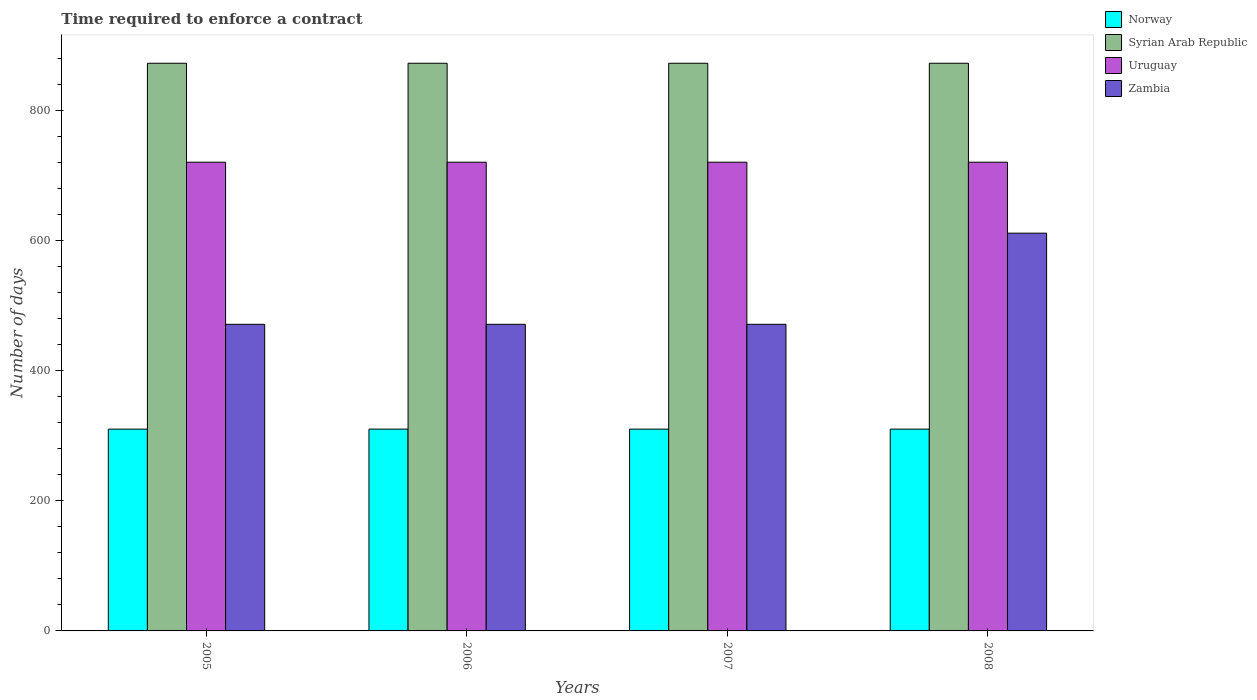How many different coloured bars are there?
Keep it short and to the point. 4. Are the number of bars per tick equal to the number of legend labels?
Make the answer very short. Yes. Are the number of bars on each tick of the X-axis equal?
Your answer should be very brief. Yes. What is the number of days required to enforce a contract in Uruguay in 2006?
Give a very brief answer. 720. Across all years, what is the maximum number of days required to enforce a contract in Syrian Arab Republic?
Ensure brevity in your answer.  872. Across all years, what is the minimum number of days required to enforce a contract in Zambia?
Ensure brevity in your answer.  471. What is the total number of days required to enforce a contract in Uruguay in the graph?
Offer a terse response. 2880. What is the difference between the number of days required to enforce a contract in Uruguay in 2007 and the number of days required to enforce a contract in Norway in 2005?
Your response must be concise. 410. What is the average number of days required to enforce a contract in Norway per year?
Your answer should be very brief. 310. In the year 2006, what is the difference between the number of days required to enforce a contract in Zambia and number of days required to enforce a contract in Uruguay?
Provide a succinct answer. -249. Is the number of days required to enforce a contract in Norway in 2006 less than that in 2008?
Offer a very short reply. No. What is the difference between the highest and the second highest number of days required to enforce a contract in Norway?
Your answer should be compact. 0. What is the difference between the highest and the lowest number of days required to enforce a contract in Uruguay?
Your answer should be very brief. 0. Is it the case that in every year, the sum of the number of days required to enforce a contract in Norway and number of days required to enforce a contract in Syrian Arab Republic is greater than the sum of number of days required to enforce a contract in Uruguay and number of days required to enforce a contract in Zambia?
Your answer should be compact. No. What does the 2nd bar from the left in 2007 represents?
Ensure brevity in your answer.  Syrian Arab Republic. What does the 2nd bar from the right in 2008 represents?
Your response must be concise. Uruguay. Are all the bars in the graph horizontal?
Provide a short and direct response. No. How many years are there in the graph?
Provide a short and direct response. 4. Does the graph contain any zero values?
Provide a short and direct response. No. Does the graph contain grids?
Offer a terse response. No. Where does the legend appear in the graph?
Provide a succinct answer. Top right. What is the title of the graph?
Your response must be concise. Time required to enforce a contract. Does "Moldova" appear as one of the legend labels in the graph?
Give a very brief answer. No. What is the label or title of the X-axis?
Keep it short and to the point. Years. What is the label or title of the Y-axis?
Your answer should be compact. Number of days. What is the Number of days of Norway in 2005?
Your answer should be very brief. 310. What is the Number of days in Syrian Arab Republic in 2005?
Ensure brevity in your answer.  872. What is the Number of days of Uruguay in 2005?
Keep it short and to the point. 720. What is the Number of days in Zambia in 2005?
Keep it short and to the point. 471. What is the Number of days in Norway in 2006?
Give a very brief answer. 310. What is the Number of days of Syrian Arab Republic in 2006?
Provide a short and direct response. 872. What is the Number of days of Uruguay in 2006?
Provide a succinct answer. 720. What is the Number of days of Zambia in 2006?
Ensure brevity in your answer.  471. What is the Number of days of Norway in 2007?
Provide a succinct answer. 310. What is the Number of days in Syrian Arab Republic in 2007?
Provide a succinct answer. 872. What is the Number of days in Uruguay in 2007?
Offer a terse response. 720. What is the Number of days of Zambia in 2007?
Your answer should be very brief. 471. What is the Number of days of Norway in 2008?
Offer a terse response. 310. What is the Number of days of Syrian Arab Republic in 2008?
Your answer should be compact. 872. What is the Number of days in Uruguay in 2008?
Provide a succinct answer. 720. What is the Number of days in Zambia in 2008?
Provide a short and direct response. 611. Across all years, what is the maximum Number of days in Norway?
Ensure brevity in your answer.  310. Across all years, what is the maximum Number of days in Syrian Arab Republic?
Your answer should be compact. 872. Across all years, what is the maximum Number of days of Uruguay?
Your answer should be compact. 720. Across all years, what is the maximum Number of days in Zambia?
Give a very brief answer. 611. Across all years, what is the minimum Number of days in Norway?
Keep it short and to the point. 310. Across all years, what is the minimum Number of days in Syrian Arab Republic?
Your response must be concise. 872. Across all years, what is the minimum Number of days of Uruguay?
Your response must be concise. 720. Across all years, what is the minimum Number of days of Zambia?
Your answer should be very brief. 471. What is the total Number of days of Norway in the graph?
Keep it short and to the point. 1240. What is the total Number of days in Syrian Arab Republic in the graph?
Your answer should be very brief. 3488. What is the total Number of days in Uruguay in the graph?
Provide a short and direct response. 2880. What is the total Number of days in Zambia in the graph?
Your answer should be very brief. 2024. What is the difference between the Number of days in Norway in 2005 and that in 2006?
Provide a short and direct response. 0. What is the difference between the Number of days in Uruguay in 2005 and that in 2006?
Offer a terse response. 0. What is the difference between the Number of days in Norway in 2005 and that in 2007?
Offer a terse response. 0. What is the difference between the Number of days in Uruguay in 2005 and that in 2007?
Offer a very short reply. 0. What is the difference between the Number of days of Norway in 2005 and that in 2008?
Give a very brief answer. 0. What is the difference between the Number of days of Syrian Arab Republic in 2005 and that in 2008?
Provide a succinct answer. 0. What is the difference between the Number of days in Zambia in 2005 and that in 2008?
Make the answer very short. -140. What is the difference between the Number of days in Norway in 2006 and that in 2007?
Offer a very short reply. 0. What is the difference between the Number of days in Zambia in 2006 and that in 2007?
Your response must be concise. 0. What is the difference between the Number of days of Norway in 2006 and that in 2008?
Provide a short and direct response. 0. What is the difference between the Number of days in Zambia in 2006 and that in 2008?
Provide a succinct answer. -140. What is the difference between the Number of days in Norway in 2007 and that in 2008?
Your response must be concise. 0. What is the difference between the Number of days of Syrian Arab Republic in 2007 and that in 2008?
Provide a succinct answer. 0. What is the difference between the Number of days in Zambia in 2007 and that in 2008?
Provide a short and direct response. -140. What is the difference between the Number of days of Norway in 2005 and the Number of days of Syrian Arab Republic in 2006?
Your answer should be very brief. -562. What is the difference between the Number of days in Norway in 2005 and the Number of days in Uruguay in 2006?
Your response must be concise. -410. What is the difference between the Number of days of Norway in 2005 and the Number of days of Zambia in 2006?
Give a very brief answer. -161. What is the difference between the Number of days of Syrian Arab Republic in 2005 and the Number of days of Uruguay in 2006?
Your answer should be compact. 152. What is the difference between the Number of days of Syrian Arab Republic in 2005 and the Number of days of Zambia in 2006?
Your response must be concise. 401. What is the difference between the Number of days of Uruguay in 2005 and the Number of days of Zambia in 2006?
Your answer should be very brief. 249. What is the difference between the Number of days in Norway in 2005 and the Number of days in Syrian Arab Republic in 2007?
Make the answer very short. -562. What is the difference between the Number of days in Norway in 2005 and the Number of days in Uruguay in 2007?
Provide a succinct answer. -410. What is the difference between the Number of days in Norway in 2005 and the Number of days in Zambia in 2007?
Make the answer very short. -161. What is the difference between the Number of days of Syrian Arab Republic in 2005 and the Number of days of Uruguay in 2007?
Give a very brief answer. 152. What is the difference between the Number of days of Syrian Arab Republic in 2005 and the Number of days of Zambia in 2007?
Your response must be concise. 401. What is the difference between the Number of days of Uruguay in 2005 and the Number of days of Zambia in 2007?
Provide a short and direct response. 249. What is the difference between the Number of days of Norway in 2005 and the Number of days of Syrian Arab Republic in 2008?
Make the answer very short. -562. What is the difference between the Number of days in Norway in 2005 and the Number of days in Uruguay in 2008?
Offer a terse response. -410. What is the difference between the Number of days in Norway in 2005 and the Number of days in Zambia in 2008?
Make the answer very short. -301. What is the difference between the Number of days of Syrian Arab Republic in 2005 and the Number of days of Uruguay in 2008?
Give a very brief answer. 152. What is the difference between the Number of days of Syrian Arab Republic in 2005 and the Number of days of Zambia in 2008?
Your response must be concise. 261. What is the difference between the Number of days of Uruguay in 2005 and the Number of days of Zambia in 2008?
Provide a short and direct response. 109. What is the difference between the Number of days in Norway in 2006 and the Number of days in Syrian Arab Republic in 2007?
Ensure brevity in your answer.  -562. What is the difference between the Number of days in Norway in 2006 and the Number of days in Uruguay in 2007?
Ensure brevity in your answer.  -410. What is the difference between the Number of days in Norway in 2006 and the Number of days in Zambia in 2007?
Provide a short and direct response. -161. What is the difference between the Number of days in Syrian Arab Republic in 2006 and the Number of days in Uruguay in 2007?
Your answer should be compact. 152. What is the difference between the Number of days of Syrian Arab Republic in 2006 and the Number of days of Zambia in 2007?
Ensure brevity in your answer.  401. What is the difference between the Number of days of Uruguay in 2006 and the Number of days of Zambia in 2007?
Give a very brief answer. 249. What is the difference between the Number of days in Norway in 2006 and the Number of days in Syrian Arab Republic in 2008?
Offer a terse response. -562. What is the difference between the Number of days of Norway in 2006 and the Number of days of Uruguay in 2008?
Offer a very short reply. -410. What is the difference between the Number of days in Norway in 2006 and the Number of days in Zambia in 2008?
Ensure brevity in your answer.  -301. What is the difference between the Number of days of Syrian Arab Republic in 2006 and the Number of days of Uruguay in 2008?
Keep it short and to the point. 152. What is the difference between the Number of days of Syrian Arab Republic in 2006 and the Number of days of Zambia in 2008?
Your response must be concise. 261. What is the difference between the Number of days of Uruguay in 2006 and the Number of days of Zambia in 2008?
Keep it short and to the point. 109. What is the difference between the Number of days of Norway in 2007 and the Number of days of Syrian Arab Republic in 2008?
Your answer should be compact. -562. What is the difference between the Number of days in Norway in 2007 and the Number of days in Uruguay in 2008?
Offer a very short reply. -410. What is the difference between the Number of days of Norway in 2007 and the Number of days of Zambia in 2008?
Keep it short and to the point. -301. What is the difference between the Number of days in Syrian Arab Republic in 2007 and the Number of days in Uruguay in 2008?
Provide a succinct answer. 152. What is the difference between the Number of days of Syrian Arab Republic in 2007 and the Number of days of Zambia in 2008?
Ensure brevity in your answer.  261. What is the difference between the Number of days of Uruguay in 2007 and the Number of days of Zambia in 2008?
Your answer should be compact. 109. What is the average Number of days of Norway per year?
Your answer should be very brief. 310. What is the average Number of days of Syrian Arab Republic per year?
Your answer should be very brief. 872. What is the average Number of days in Uruguay per year?
Offer a terse response. 720. What is the average Number of days of Zambia per year?
Provide a succinct answer. 506. In the year 2005, what is the difference between the Number of days in Norway and Number of days in Syrian Arab Republic?
Keep it short and to the point. -562. In the year 2005, what is the difference between the Number of days in Norway and Number of days in Uruguay?
Your answer should be compact. -410. In the year 2005, what is the difference between the Number of days in Norway and Number of days in Zambia?
Ensure brevity in your answer.  -161. In the year 2005, what is the difference between the Number of days in Syrian Arab Republic and Number of days in Uruguay?
Offer a terse response. 152. In the year 2005, what is the difference between the Number of days of Syrian Arab Republic and Number of days of Zambia?
Provide a succinct answer. 401. In the year 2005, what is the difference between the Number of days of Uruguay and Number of days of Zambia?
Your response must be concise. 249. In the year 2006, what is the difference between the Number of days of Norway and Number of days of Syrian Arab Republic?
Make the answer very short. -562. In the year 2006, what is the difference between the Number of days in Norway and Number of days in Uruguay?
Provide a succinct answer. -410. In the year 2006, what is the difference between the Number of days in Norway and Number of days in Zambia?
Your answer should be very brief. -161. In the year 2006, what is the difference between the Number of days of Syrian Arab Republic and Number of days of Uruguay?
Provide a succinct answer. 152. In the year 2006, what is the difference between the Number of days in Syrian Arab Republic and Number of days in Zambia?
Offer a terse response. 401. In the year 2006, what is the difference between the Number of days of Uruguay and Number of days of Zambia?
Keep it short and to the point. 249. In the year 2007, what is the difference between the Number of days in Norway and Number of days in Syrian Arab Republic?
Your answer should be very brief. -562. In the year 2007, what is the difference between the Number of days of Norway and Number of days of Uruguay?
Provide a short and direct response. -410. In the year 2007, what is the difference between the Number of days in Norway and Number of days in Zambia?
Your answer should be very brief. -161. In the year 2007, what is the difference between the Number of days in Syrian Arab Republic and Number of days in Uruguay?
Your response must be concise. 152. In the year 2007, what is the difference between the Number of days of Syrian Arab Republic and Number of days of Zambia?
Give a very brief answer. 401. In the year 2007, what is the difference between the Number of days of Uruguay and Number of days of Zambia?
Your response must be concise. 249. In the year 2008, what is the difference between the Number of days in Norway and Number of days in Syrian Arab Republic?
Offer a very short reply. -562. In the year 2008, what is the difference between the Number of days in Norway and Number of days in Uruguay?
Your response must be concise. -410. In the year 2008, what is the difference between the Number of days of Norway and Number of days of Zambia?
Provide a succinct answer. -301. In the year 2008, what is the difference between the Number of days of Syrian Arab Republic and Number of days of Uruguay?
Make the answer very short. 152. In the year 2008, what is the difference between the Number of days in Syrian Arab Republic and Number of days in Zambia?
Offer a terse response. 261. In the year 2008, what is the difference between the Number of days of Uruguay and Number of days of Zambia?
Keep it short and to the point. 109. What is the ratio of the Number of days of Norway in 2005 to that in 2006?
Offer a terse response. 1. What is the ratio of the Number of days in Uruguay in 2005 to that in 2006?
Keep it short and to the point. 1. What is the ratio of the Number of days of Norway in 2005 to that in 2007?
Your answer should be very brief. 1. What is the ratio of the Number of days in Uruguay in 2005 to that in 2008?
Provide a succinct answer. 1. What is the ratio of the Number of days of Zambia in 2005 to that in 2008?
Provide a succinct answer. 0.77. What is the ratio of the Number of days in Norway in 2006 to that in 2007?
Make the answer very short. 1. What is the ratio of the Number of days in Uruguay in 2006 to that in 2007?
Keep it short and to the point. 1. What is the ratio of the Number of days in Zambia in 2006 to that in 2008?
Your answer should be very brief. 0.77. What is the ratio of the Number of days of Syrian Arab Republic in 2007 to that in 2008?
Ensure brevity in your answer.  1. What is the ratio of the Number of days in Zambia in 2007 to that in 2008?
Your answer should be very brief. 0.77. What is the difference between the highest and the second highest Number of days of Norway?
Offer a terse response. 0. What is the difference between the highest and the second highest Number of days in Syrian Arab Republic?
Your response must be concise. 0. What is the difference between the highest and the second highest Number of days of Zambia?
Your answer should be compact. 140. What is the difference between the highest and the lowest Number of days of Zambia?
Provide a succinct answer. 140. 